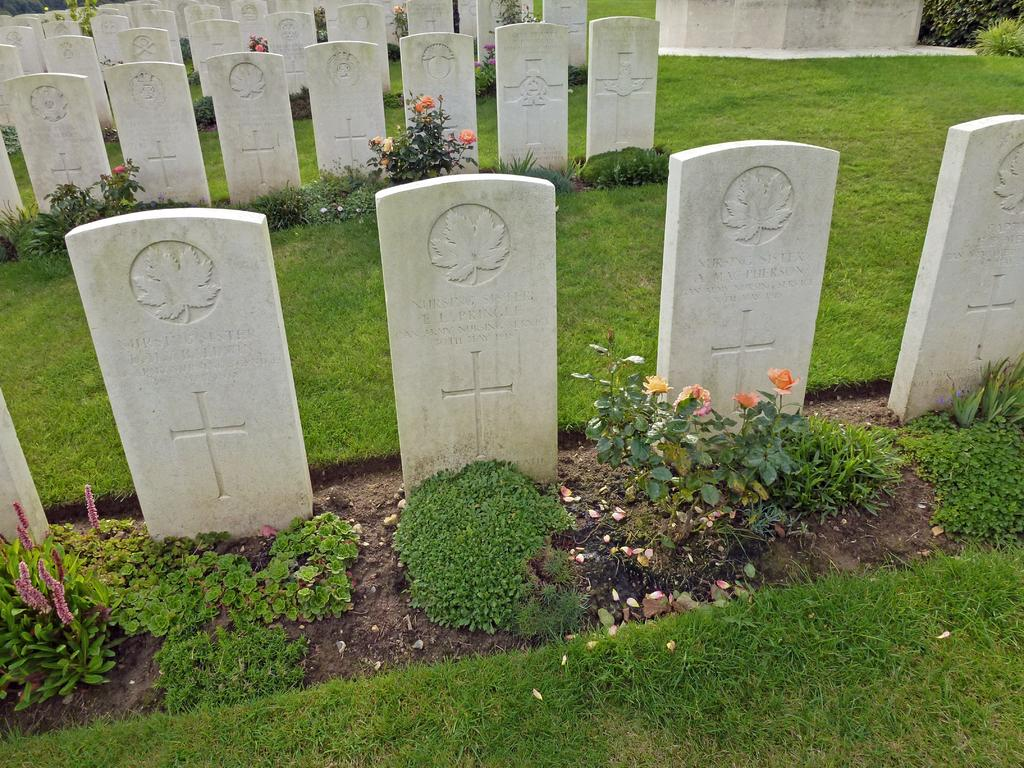What type of location is depicted in the image? The image contains cemeteries. What can be seen in the cemeteries? There are flowers in the image. How many colors are present in the flowers? The flowers are in multiple colors. What is the color of the grass in the image? The grass is green in the image. What type of skirt is being worn by the boundary in the image? There is no skirt or boundary present in the image; it features cemeteries, flowers, and green grass. 